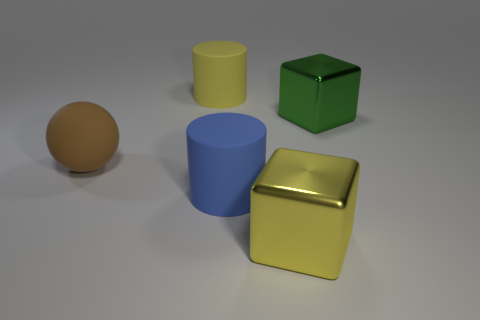Add 3 large matte objects. How many objects exist? 8 Add 4 brown rubber things. How many brown rubber things are left? 5 Add 4 large cyan matte objects. How many large cyan matte objects exist? 4 Subtract 0 blue spheres. How many objects are left? 5 Subtract all blocks. How many objects are left? 3 Subtract all brown blocks. Subtract all blue spheres. How many blocks are left? 2 Subtract all yellow matte cylinders. Subtract all big rubber balls. How many objects are left? 3 